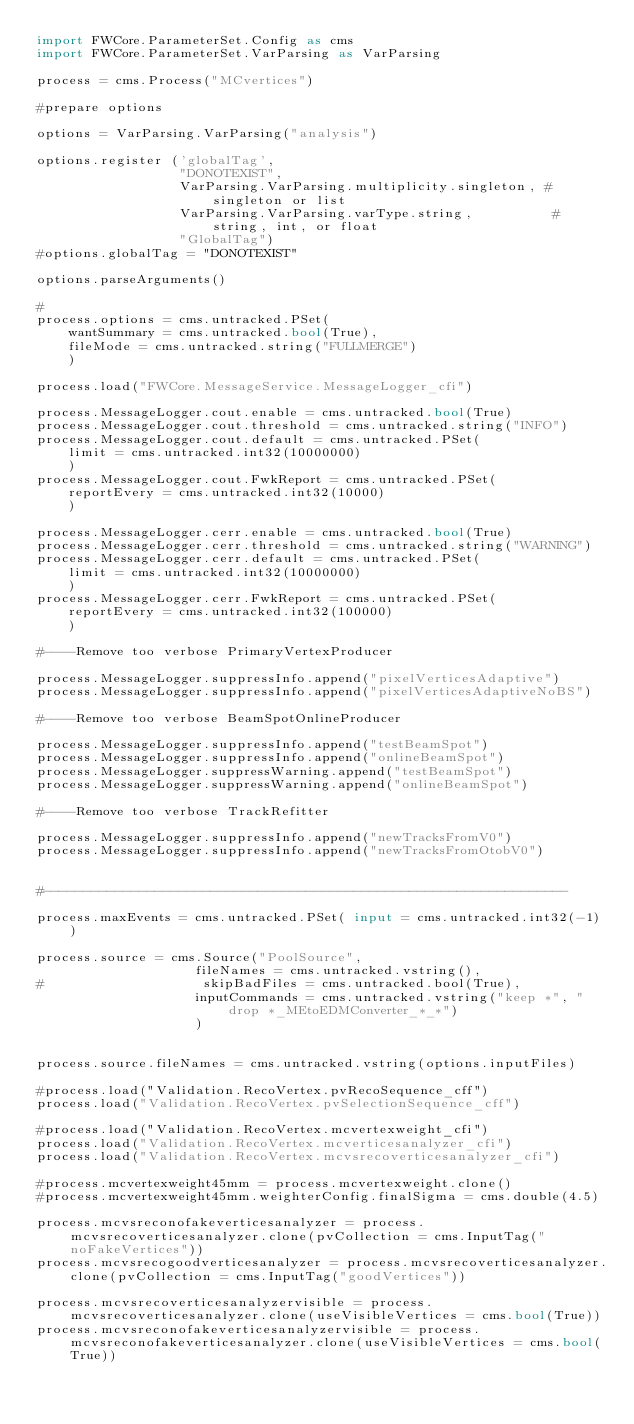<code> <loc_0><loc_0><loc_500><loc_500><_Python_>import FWCore.ParameterSet.Config as cms
import FWCore.ParameterSet.VarParsing as VarParsing

process = cms.Process("MCvertices")

#prepare options

options = VarParsing.VarParsing("analysis")

options.register ('globalTag',
                  "DONOTEXIST",
                  VarParsing.VarParsing.multiplicity.singleton, # singleton or list
                  VarParsing.VarParsing.varType.string,          # string, int, or float
                  "GlobalTag")
#options.globalTag = "DONOTEXIST"

options.parseArguments()

#
process.options = cms.untracked.PSet(
    wantSummary = cms.untracked.bool(True),
    fileMode = cms.untracked.string("FULLMERGE")
    )

process.load("FWCore.MessageService.MessageLogger_cfi")

process.MessageLogger.cout.enable = cms.untracked.bool(True)
process.MessageLogger.cout.threshold = cms.untracked.string("INFO")
process.MessageLogger.cout.default = cms.untracked.PSet(
    limit = cms.untracked.int32(10000000)
    )
process.MessageLogger.cout.FwkReport = cms.untracked.PSet(
    reportEvery = cms.untracked.int32(10000)
    )

process.MessageLogger.cerr.enable = cms.untracked.bool(True)
process.MessageLogger.cerr.threshold = cms.untracked.string("WARNING")
process.MessageLogger.cerr.default = cms.untracked.PSet(
    limit = cms.untracked.int32(10000000)
    )
process.MessageLogger.cerr.FwkReport = cms.untracked.PSet(
    reportEvery = cms.untracked.int32(100000)
    )

#----Remove too verbose PrimaryVertexProducer

process.MessageLogger.suppressInfo.append("pixelVerticesAdaptive")
process.MessageLogger.suppressInfo.append("pixelVerticesAdaptiveNoBS")

#----Remove too verbose BeamSpotOnlineProducer

process.MessageLogger.suppressInfo.append("testBeamSpot")
process.MessageLogger.suppressInfo.append("onlineBeamSpot")
process.MessageLogger.suppressWarning.append("testBeamSpot")
process.MessageLogger.suppressWarning.append("onlineBeamSpot")

#----Remove too verbose TrackRefitter

process.MessageLogger.suppressInfo.append("newTracksFromV0")
process.MessageLogger.suppressInfo.append("newTracksFromOtobV0")


#------------------------------------------------------------------

process.maxEvents = cms.untracked.PSet( input = cms.untracked.int32(-1) )

process.source = cms.Source("PoolSource",
                    fileNames = cms.untracked.vstring(),
#                    skipBadFiles = cms.untracked.bool(True),
                    inputCommands = cms.untracked.vstring("keep *", "drop *_MEtoEDMConverter_*_*")
                    )


process.source.fileNames = cms.untracked.vstring(options.inputFiles)

#process.load("Validation.RecoVertex.pvRecoSequence_cff")
process.load("Validation.RecoVertex.pvSelectionSequence_cff")

#process.load("Validation.RecoVertex.mcvertexweight_cfi")
process.load("Validation.RecoVertex.mcverticesanalyzer_cfi")
process.load("Validation.RecoVertex.mcvsrecoverticesanalyzer_cfi")

#process.mcvertexweight45mm = process.mcvertexweight.clone()
#process.mcvertexweight45mm.weighterConfig.finalSigma = cms.double(4.5)

process.mcvsreconofakeverticesanalyzer = process.mcvsrecoverticesanalyzer.clone(pvCollection = cms.InputTag("noFakeVertices"))
process.mcvsrecogoodverticesanalyzer = process.mcvsrecoverticesanalyzer.clone(pvCollection = cms.InputTag("goodVertices"))

process.mcvsrecoverticesanalyzervisible = process.mcvsrecoverticesanalyzer.clone(useVisibleVertices = cms.bool(True))
process.mcvsreconofakeverticesanalyzervisible = process.mcvsreconofakeverticesanalyzer.clone(useVisibleVertices = cms.bool(True))</code> 